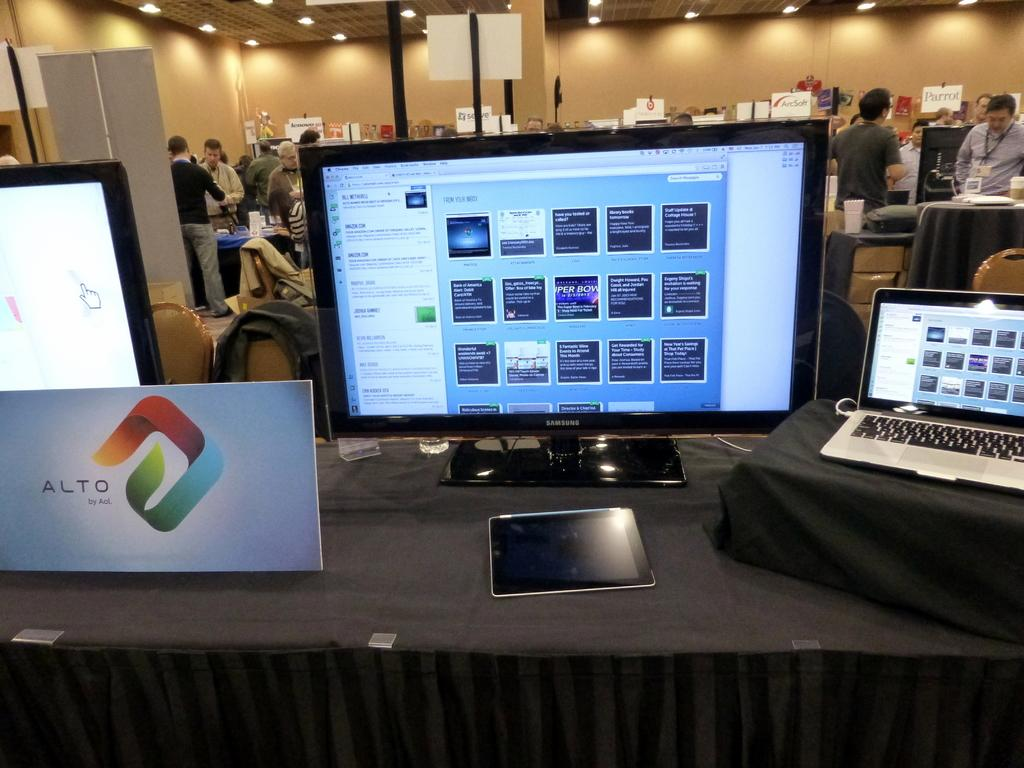<image>
Create a compact narrative representing the image presented. a sign that appears to be from Alto that has an interesting design on it 